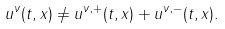<formula> <loc_0><loc_0><loc_500><loc_500>u ^ { \nu } ( t , x ) \not = u ^ { \nu , + } ( t , x ) + u ^ { \nu , - } ( t , x ) .</formula> 